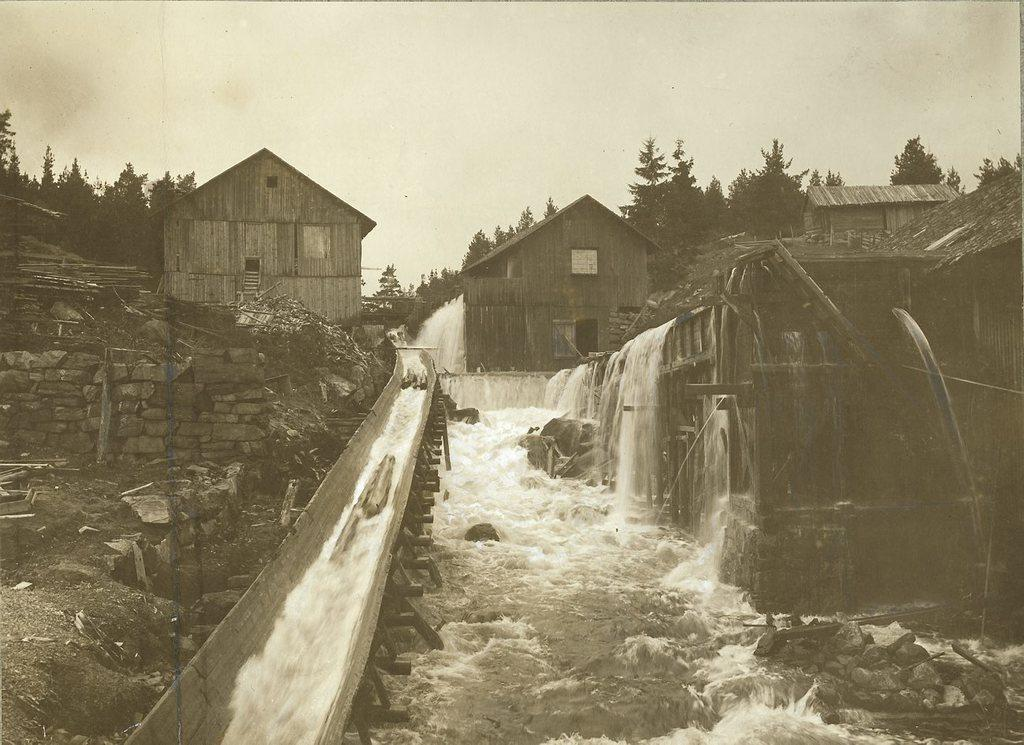What type of buildings are in the image? There are wooden buildings in the image. What is happening between the buildings? Water is flowing between the buildings. What can be seen in the background of the image? There are trees in the background of the image. How would you describe the sky in the image? The sky is clear in the image. Can you tell if the image is old or new? The image appears to be old. What type of nut is being used to plough the field in the image? There is no field or ploughing activity depicted in the image; it features wooden buildings, flowing water, trees, and a clear sky. 